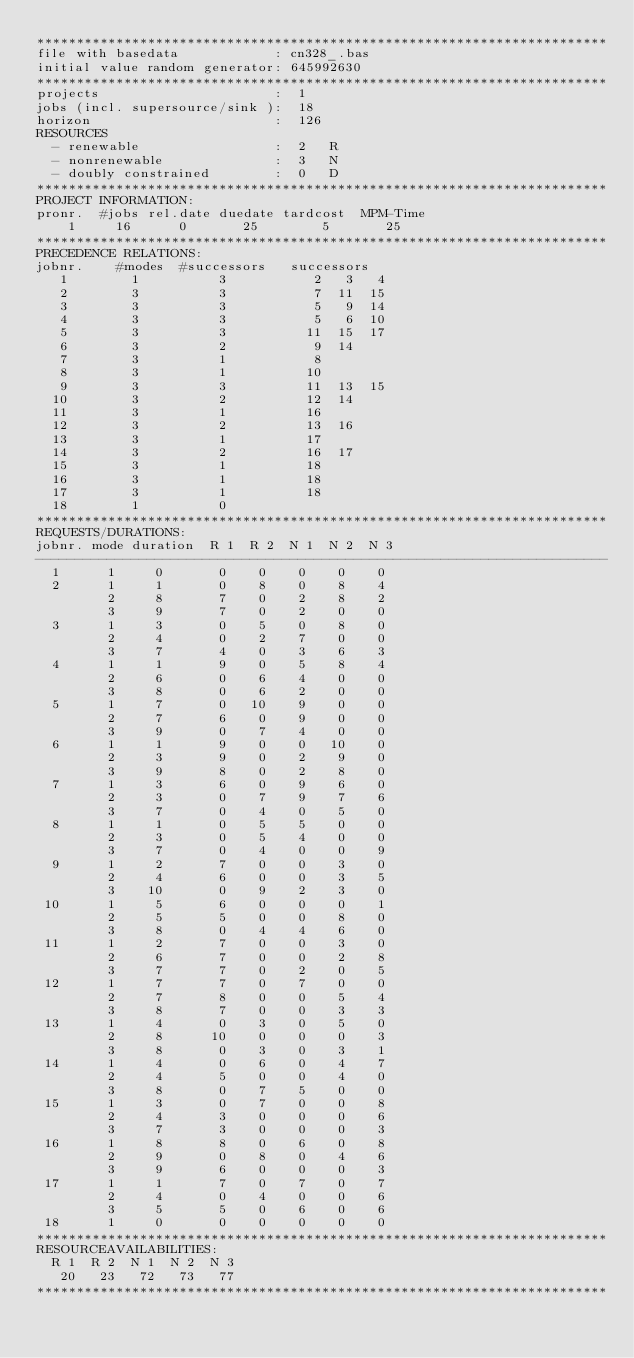Convert code to text. <code><loc_0><loc_0><loc_500><loc_500><_ObjectiveC_>************************************************************************
file with basedata            : cn328_.bas
initial value random generator: 645992630
************************************************************************
projects                      :  1
jobs (incl. supersource/sink ):  18
horizon                       :  126
RESOURCES
  - renewable                 :  2   R
  - nonrenewable              :  3   N
  - doubly constrained        :  0   D
************************************************************************
PROJECT INFORMATION:
pronr.  #jobs rel.date duedate tardcost  MPM-Time
    1     16      0       25        5       25
************************************************************************
PRECEDENCE RELATIONS:
jobnr.    #modes  #successors   successors
   1        1          3           2   3   4
   2        3          3           7  11  15
   3        3          3           5   9  14
   4        3          3           5   6  10
   5        3          3          11  15  17
   6        3          2           9  14
   7        3          1           8
   8        3          1          10
   9        3          3          11  13  15
  10        3          2          12  14
  11        3          1          16
  12        3          2          13  16
  13        3          1          17
  14        3          2          16  17
  15        3          1          18
  16        3          1          18
  17        3          1          18
  18        1          0        
************************************************************************
REQUESTS/DURATIONS:
jobnr. mode duration  R 1  R 2  N 1  N 2  N 3
------------------------------------------------------------------------
  1      1     0       0    0    0    0    0
  2      1     1       0    8    0    8    4
         2     8       7    0    2    8    2
         3     9       7    0    2    0    0
  3      1     3       0    5    0    8    0
         2     4       0    2    7    0    0
         3     7       4    0    3    6    3
  4      1     1       9    0    5    8    4
         2     6       0    6    4    0    0
         3     8       0    6    2    0    0
  5      1     7       0   10    9    0    0
         2     7       6    0    9    0    0
         3     9       0    7    4    0    0
  6      1     1       9    0    0   10    0
         2     3       9    0    2    9    0
         3     9       8    0    2    8    0
  7      1     3       6    0    9    6    0
         2     3       0    7    9    7    6
         3     7       0    4    0    5    0
  8      1     1       0    5    5    0    0
         2     3       0    5    4    0    0
         3     7       0    4    0    0    9
  9      1     2       7    0    0    3    0
         2     4       6    0    0    3    5
         3    10       0    9    2    3    0
 10      1     5       6    0    0    0    1
         2     5       5    0    0    8    0
         3     8       0    4    4    6    0
 11      1     2       7    0    0    3    0
         2     6       7    0    0    2    8
         3     7       7    0    2    0    5
 12      1     7       7    0    7    0    0
         2     7       8    0    0    5    4
         3     8       7    0    0    3    3
 13      1     4       0    3    0    5    0
         2     8      10    0    0    0    3
         3     8       0    3    0    3    1
 14      1     4       0    6    0    4    7
         2     4       5    0    0    4    0
         3     8       0    7    5    0    0
 15      1     3       0    7    0    0    8
         2     4       3    0    0    0    6
         3     7       3    0    0    0    3
 16      1     8       8    0    6    0    8
         2     9       0    8    0    4    6
         3     9       6    0    0    0    3
 17      1     1       7    0    7    0    7
         2     4       0    4    0    0    6
         3     5       5    0    6    0    6
 18      1     0       0    0    0    0    0
************************************************************************
RESOURCEAVAILABILITIES:
  R 1  R 2  N 1  N 2  N 3
   20   23   72   73   77
************************************************************************
</code> 